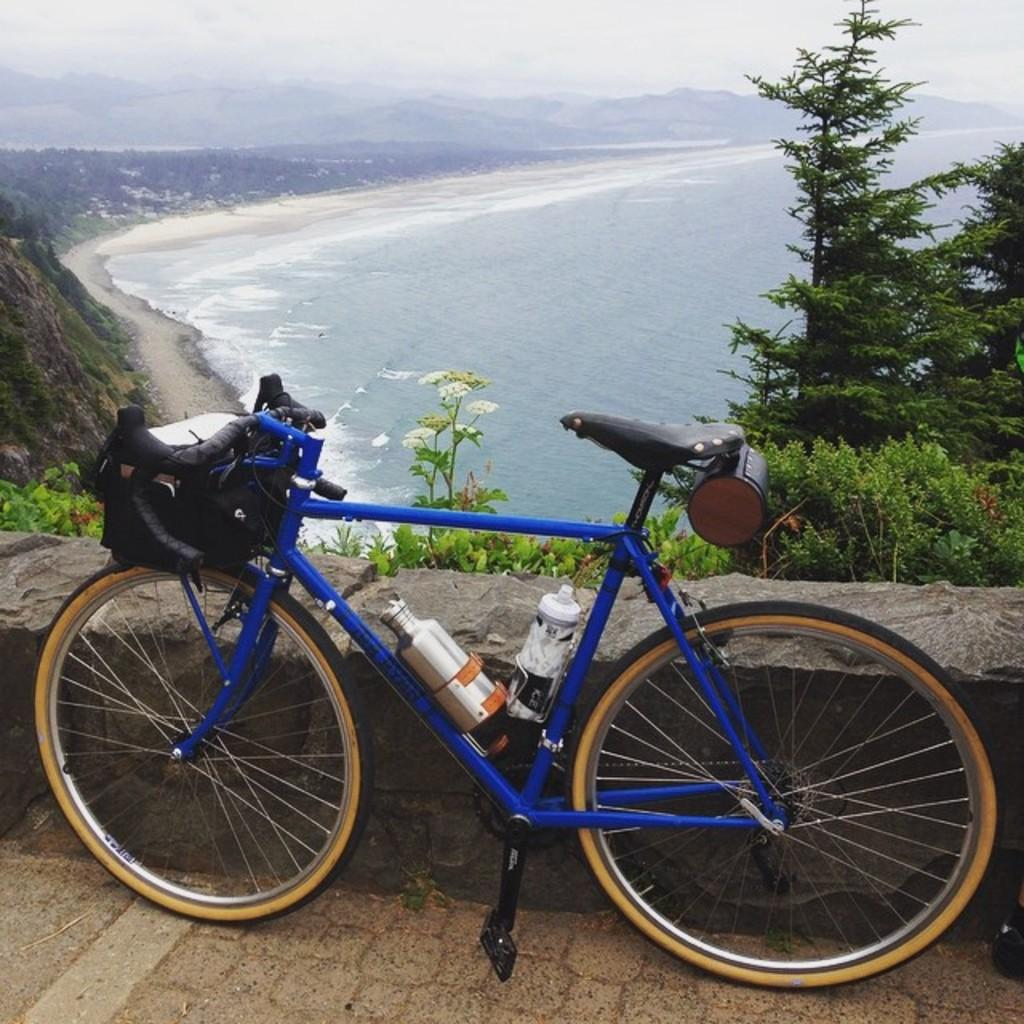What is the main subject of the image? There is a bicycle on the road in the image. What can be seen in the background of the image? Mountains, trees, and the sky are visible in the background of the image. What is visible at the bottom of the image? There is water visible at the bottom of the image. What type of flower can be seen blooming in the water at the bottom of the image? There are no flowers visible in the water at the bottom of the image. 